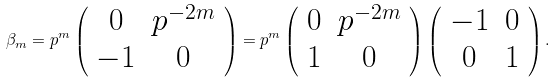Convert formula to latex. <formula><loc_0><loc_0><loc_500><loc_500>\beta _ { m } = p ^ { m } \left ( \begin{array} { c c } 0 & p ^ { - 2 m } \\ - 1 & 0 \end{array} \right ) = p ^ { m } \left ( \begin{array} { c c } 0 & p ^ { - 2 m } \\ 1 & 0 \end{array} \right ) \left ( \begin{array} { c c } - 1 & 0 \\ 0 & 1 \end{array} \right ) .</formula> 